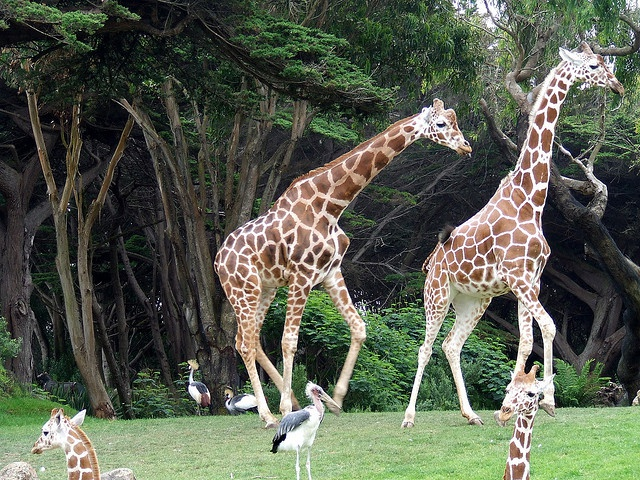Describe the objects in this image and their specific colors. I can see giraffe in darkgreen, white, brown, darkgray, and black tones, giraffe in darkgreen, white, gray, tan, and black tones, giraffe in darkgreen, white, darkgray, gray, and tan tones, giraffe in darkgreen, white, darkgray, and tan tones, and bird in darkgreen, white, darkgray, beige, and black tones in this image. 